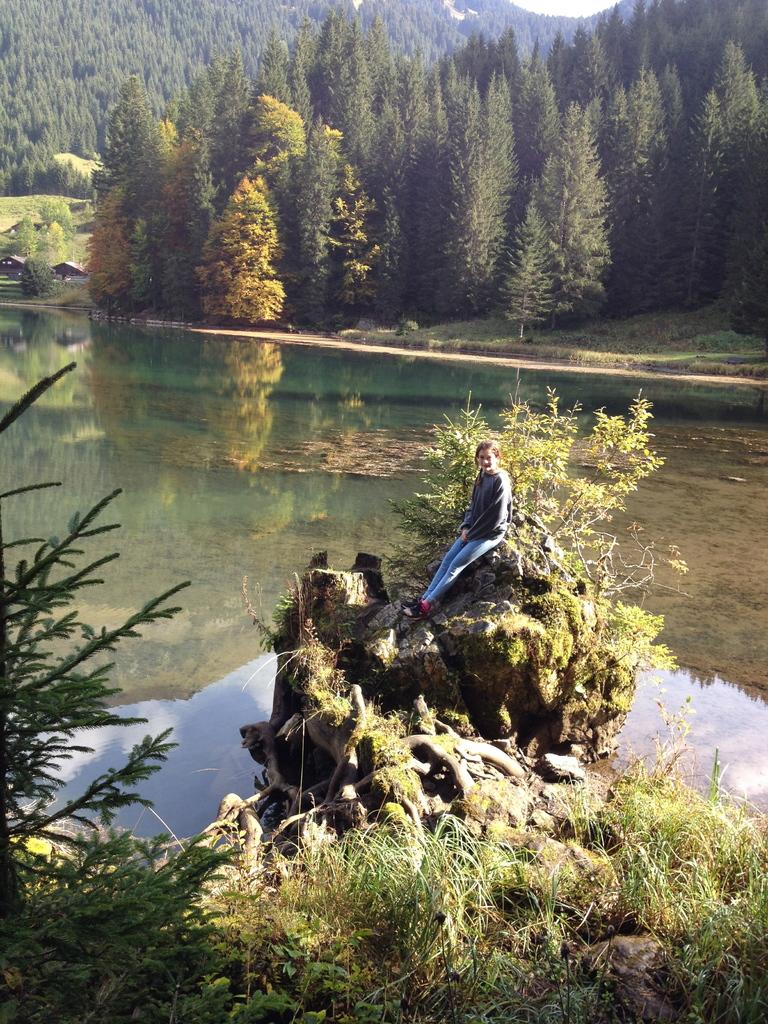What type of natural elements can be seen in the image? There are trees and water visible in the image. What other living organisms can be seen in the image? There are plants in the image. What is the woman in the image doing? The woman is seated on a rock in the image. What type of shoe is the woman wearing in the image? There is no shoe visible in the image, as the woman is seated on a rock without any footwear. Can you tell me about the beliefs of the bubbles in the image? There are no bubbles present in the image, so it is not possible to discuss their beliefs. 